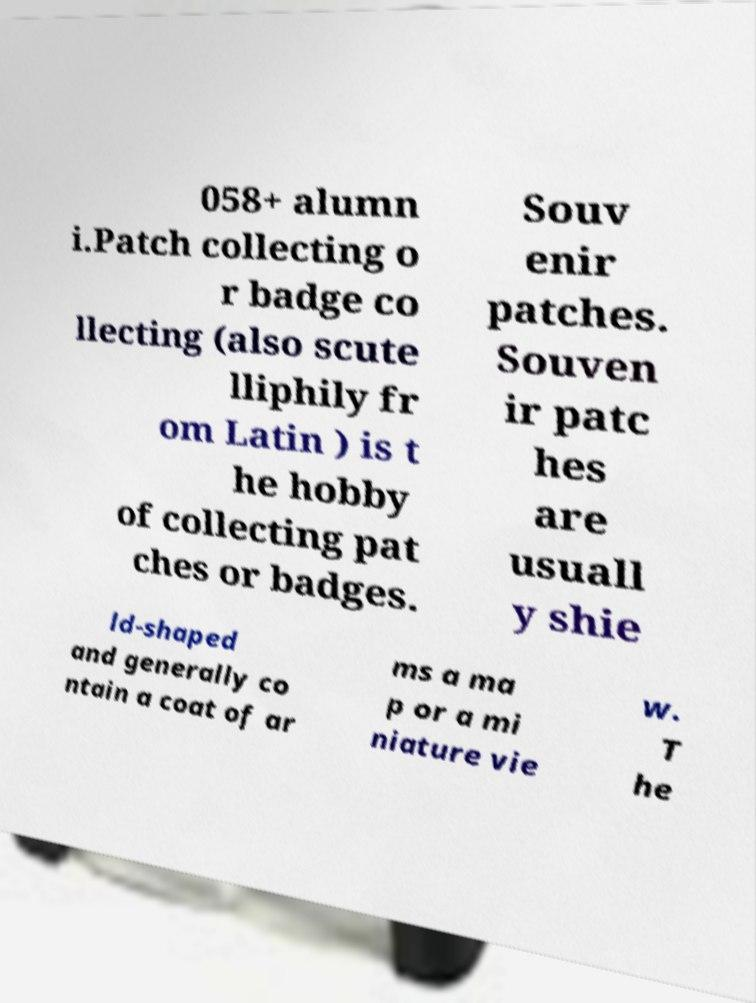There's text embedded in this image that I need extracted. Can you transcribe it verbatim? 058+ alumn i.Patch collecting o r badge co llecting (also scute lliphily fr om Latin ) is t he hobby of collecting pat ches or badges. Souv enir patches. Souven ir patc hes are usuall y shie ld-shaped and generally co ntain a coat of ar ms a ma p or a mi niature vie w. T he 